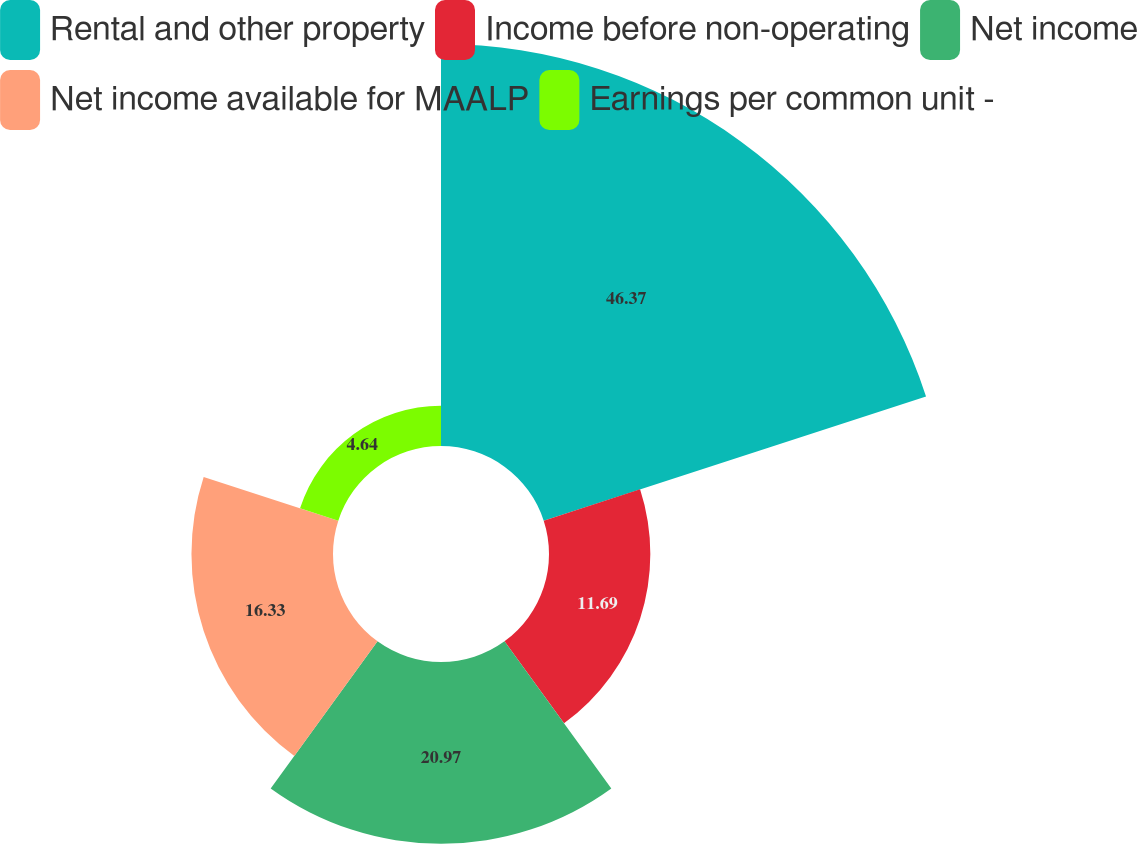Convert chart. <chart><loc_0><loc_0><loc_500><loc_500><pie_chart><fcel>Rental and other property<fcel>Income before non-operating<fcel>Net income<fcel>Net income available for MAALP<fcel>Earnings per common unit -<nl><fcel>46.38%<fcel>11.69%<fcel>20.97%<fcel>16.33%<fcel>4.64%<nl></chart> 